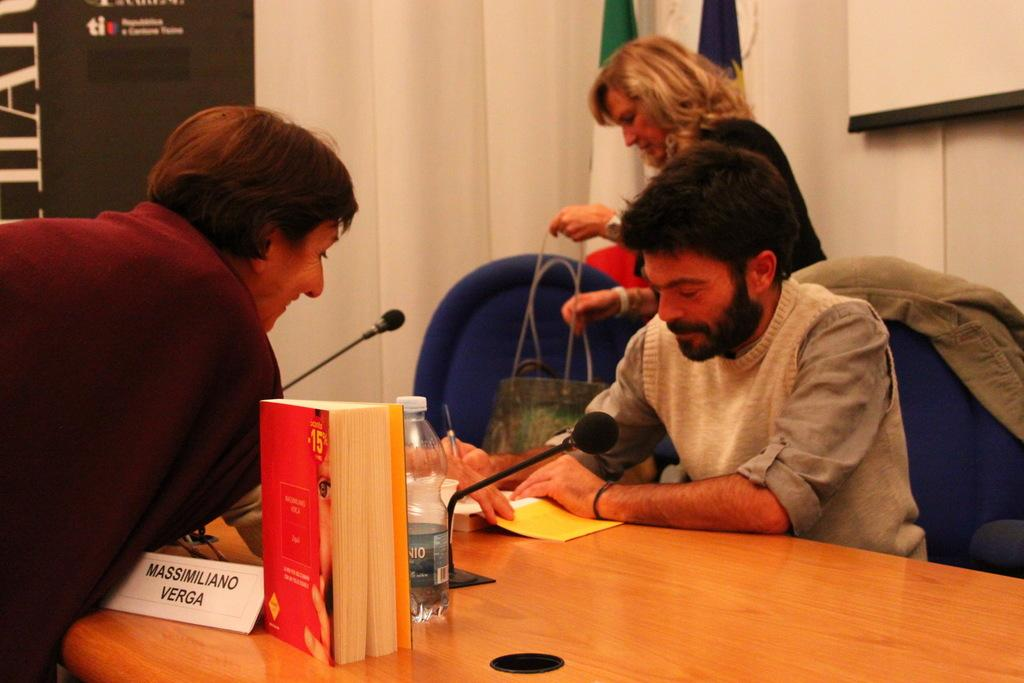<image>
Create a compact narrative representing the image presented. A person is leaning over a name card that says Massimiliano Verga on it. 